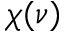<formula> <loc_0><loc_0><loc_500><loc_500>\chi ( \nu )</formula> 